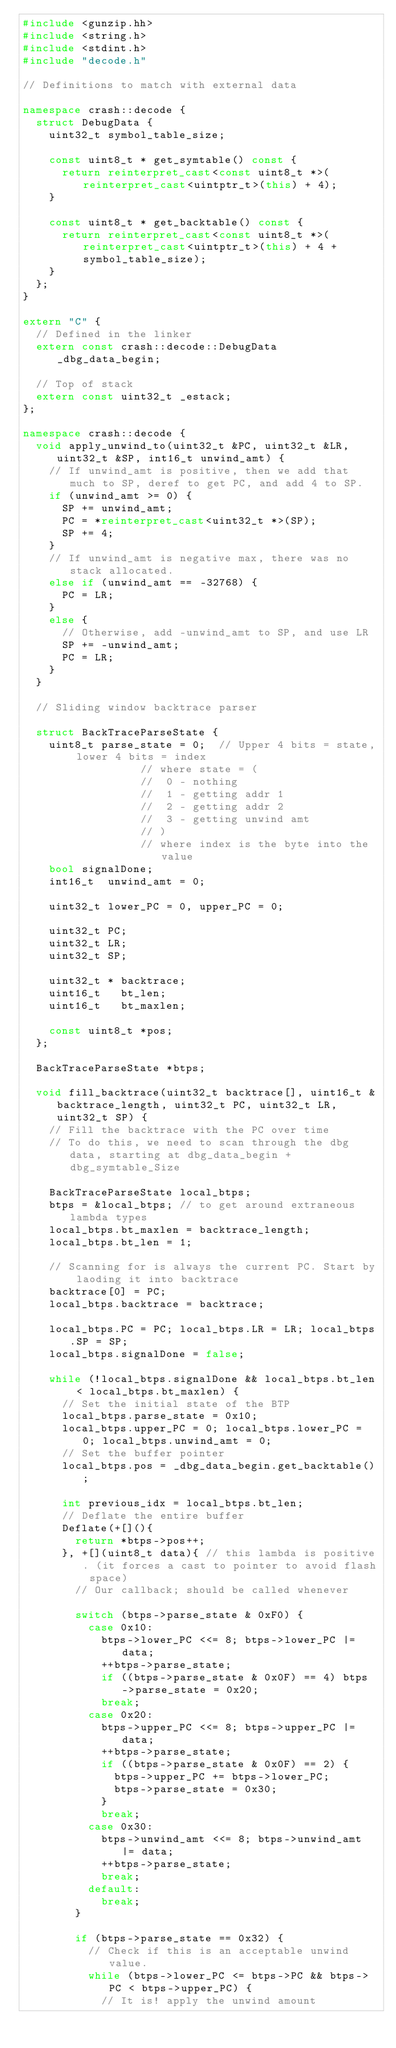Convert code to text. <code><loc_0><loc_0><loc_500><loc_500><_C++_>#include <gunzip.hh>
#include <string.h>
#include <stdint.h>
#include "decode.h"

// Definitions to match with external data

namespace crash::decode {
	struct DebugData {
		uint32_t symbol_table_size;

		const uint8_t * get_symtable() const {
			return reinterpret_cast<const uint8_t *>(reinterpret_cast<uintptr_t>(this) + 4);
		}

		const uint8_t * get_backtable() const {
			return reinterpret_cast<const uint8_t *>(reinterpret_cast<uintptr_t>(this) + 4 + symbol_table_size);
		}
	};
}

extern "C" {
	// Defined in the linker
	extern const crash::decode::DebugData _dbg_data_begin;

	// Top of stack
	extern const uint32_t _estack;
};

namespace crash::decode {
	void apply_unwind_to(uint32_t &PC, uint32_t &LR, uint32_t &SP, int16_t unwind_amt) {
		// If unwind_amt is positive, then we add that much to SP, deref to get PC, and add 4 to SP.
		if (unwind_amt >= 0) {
			SP += unwind_amt;
			PC = *reinterpret_cast<uint32_t *>(SP);
			SP += 4;
		}
		// If unwind_amt is negative max, there was no stack allocated.
		else if (unwind_amt == -32768) {
			PC = LR;
		}
		else {
			// Otherwise, add -unwind_amt to SP, and use LR
			SP += -unwind_amt;
			PC = LR;
		}
	}

	// Sliding window backtrace parser
	
	struct BackTraceParseState {
		uint8_t parse_state = 0;  // Upper 4 bits = state, lower 4 bits = index
								  // where state = (
								  // 	0 - nothing
								  // 	1 - getting addr 1
								  // 	2 - getting addr 2
								  // 	3 - getting unwind amt
								  // )
								  // where index is the byte into the value
		bool signalDone;
		int16_t  unwind_amt = 0;

		uint32_t lower_PC = 0, upper_PC = 0;
		
		uint32_t PC;
		uint32_t LR;
		uint32_t SP;

		uint32_t * backtrace;
		uint16_t   bt_len;
		uint16_t   bt_maxlen;

		const uint8_t *pos;
	};

	BackTraceParseState *btps;

	void fill_backtrace(uint32_t backtrace[], uint16_t &backtrace_length, uint32_t PC, uint32_t LR, uint32_t SP) {
		// Fill the backtrace with the PC over time
		// To do this, we need to scan through the dbg data, starting at dbg_data_begin + dbg_symtable_Size
		
		BackTraceParseState local_btps;
		btps = &local_btps; // to get around extraneous lambda types
		local_btps.bt_maxlen = backtrace_length;
		local_btps.bt_len = 1;

		// Scanning for is always the current PC. Start by laoding it into backtrace
		backtrace[0] = PC;
		local_btps.backtrace = backtrace;

		local_btps.PC = PC; local_btps.LR = LR; local_btps.SP = SP;
		local_btps.signalDone = false;

		while (!local_btps.signalDone && local_btps.bt_len < local_btps.bt_maxlen) {
			// Set the initial state of the BTP
			local_btps.parse_state = 0x10;
			local_btps.upper_PC = 0; local_btps.lower_PC = 0; local_btps.unwind_amt = 0;
			// Set the buffer pointer
			local_btps.pos = _dbg_data_begin.get_backtable();

			int previous_idx = local_btps.bt_len;
			// Deflate the entire buffer
			Deflate(+[](){
				return *btps->pos++;
			}, +[](uint8_t data){ // this lambda is positive. (it forces a cast to pointer to avoid flash space)
				// Our callback; should be called whenever
				
				switch (btps->parse_state & 0xF0) {
					case 0x10:
						btps->lower_PC <<= 8; btps->lower_PC |= data;
						++btps->parse_state;
						if ((btps->parse_state & 0x0F) == 4) btps->parse_state = 0x20;
						break;
					case 0x20:
						btps->upper_PC <<= 8; btps->upper_PC |= data;
						++btps->parse_state;
						if ((btps->parse_state & 0x0F) == 2) {
							btps->upper_PC += btps->lower_PC;
							btps->parse_state = 0x30;
						}
						break;
					case 0x30:
						btps->unwind_amt <<= 8; btps->unwind_amt |= data;
						++btps->parse_state;
						break;
					default:
						break;
				}

				if (btps->parse_state == 0x32) {
					// Check if this is an acceptable unwind value.
					while (btps->lower_PC <= btps->PC && btps->PC < btps->upper_PC) {
						// It is! apply the unwind amount</code> 